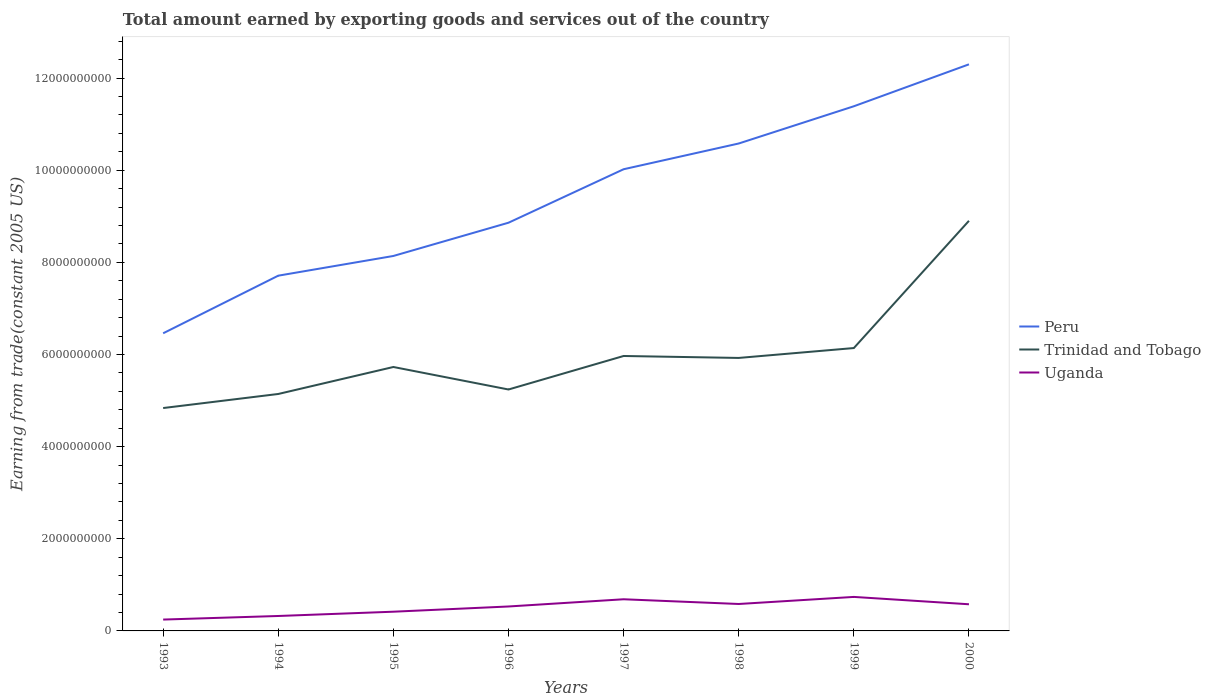Does the line corresponding to Peru intersect with the line corresponding to Trinidad and Tobago?
Make the answer very short. No. Is the number of lines equal to the number of legend labels?
Offer a very short reply. Yes. Across all years, what is the maximum total amount earned by exporting goods and services in Peru?
Give a very brief answer. 6.46e+09. In which year was the total amount earned by exporting goods and services in Trinidad and Tobago maximum?
Keep it short and to the point. 1993. What is the total total amount earned by exporting goods and services in Trinidad and Tobago in the graph?
Make the answer very short. -2.98e+09. What is the difference between the highest and the second highest total amount earned by exporting goods and services in Peru?
Give a very brief answer. 5.84e+09. How many lines are there?
Your response must be concise. 3. Are the values on the major ticks of Y-axis written in scientific E-notation?
Offer a very short reply. No. Does the graph contain grids?
Your response must be concise. No. How are the legend labels stacked?
Keep it short and to the point. Vertical. What is the title of the graph?
Offer a terse response. Total amount earned by exporting goods and services out of the country. What is the label or title of the Y-axis?
Your response must be concise. Earning from trade(constant 2005 US). What is the Earning from trade(constant 2005 US) of Peru in 1993?
Your answer should be compact. 6.46e+09. What is the Earning from trade(constant 2005 US) in Trinidad and Tobago in 1993?
Ensure brevity in your answer.  4.84e+09. What is the Earning from trade(constant 2005 US) in Uganda in 1993?
Offer a very short reply. 2.46e+08. What is the Earning from trade(constant 2005 US) in Peru in 1994?
Give a very brief answer. 7.71e+09. What is the Earning from trade(constant 2005 US) of Trinidad and Tobago in 1994?
Provide a succinct answer. 5.14e+09. What is the Earning from trade(constant 2005 US) in Uganda in 1994?
Your answer should be very brief. 3.24e+08. What is the Earning from trade(constant 2005 US) in Peru in 1995?
Provide a succinct answer. 8.14e+09. What is the Earning from trade(constant 2005 US) of Trinidad and Tobago in 1995?
Keep it short and to the point. 5.73e+09. What is the Earning from trade(constant 2005 US) of Uganda in 1995?
Ensure brevity in your answer.  4.17e+08. What is the Earning from trade(constant 2005 US) in Peru in 1996?
Provide a succinct answer. 8.86e+09. What is the Earning from trade(constant 2005 US) of Trinidad and Tobago in 1996?
Ensure brevity in your answer.  5.24e+09. What is the Earning from trade(constant 2005 US) of Uganda in 1996?
Your answer should be very brief. 5.31e+08. What is the Earning from trade(constant 2005 US) of Peru in 1997?
Provide a succinct answer. 1.00e+1. What is the Earning from trade(constant 2005 US) of Trinidad and Tobago in 1997?
Ensure brevity in your answer.  5.97e+09. What is the Earning from trade(constant 2005 US) in Uganda in 1997?
Your answer should be compact. 6.87e+08. What is the Earning from trade(constant 2005 US) in Peru in 1998?
Your answer should be very brief. 1.06e+1. What is the Earning from trade(constant 2005 US) in Trinidad and Tobago in 1998?
Provide a succinct answer. 5.93e+09. What is the Earning from trade(constant 2005 US) of Uganda in 1998?
Your answer should be very brief. 5.85e+08. What is the Earning from trade(constant 2005 US) in Peru in 1999?
Offer a terse response. 1.14e+1. What is the Earning from trade(constant 2005 US) of Trinidad and Tobago in 1999?
Keep it short and to the point. 6.14e+09. What is the Earning from trade(constant 2005 US) of Uganda in 1999?
Offer a terse response. 7.38e+08. What is the Earning from trade(constant 2005 US) in Peru in 2000?
Provide a succinct answer. 1.23e+1. What is the Earning from trade(constant 2005 US) in Trinidad and Tobago in 2000?
Your answer should be compact. 8.90e+09. What is the Earning from trade(constant 2005 US) in Uganda in 2000?
Your response must be concise. 5.79e+08. Across all years, what is the maximum Earning from trade(constant 2005 US) of Peru?
Provide a succinct answer. 1.23e+1. Across all years, what is the maximum Earning from trade(constant 2005 US) in Trinidad and Tobago?
Give a very brief answer. 8.90e+09. Across all years, what is the maximum Earning from trade(constant 2005 US) of Uganda?
Your response must be concise. 7.38e+08. Across all years, what is the minimum Earning from trade(constant 2005 US) in Peru?
Your answer should be compact. 6.46e+09. Across all years, what is the minimum Earning from trade(constant 2005 US) of Trinidad and Tobago?
Your response must be concise. 4.84e+09. Across all years, what is the minimum Earning from trade(constant 2005 US) of Uganda?
Give a very brief answer. 2.46e+08. What is the total Earning from trade(constant 2005 US) of Peru in the graph?
Offer a very short reply. 7.55e+1. What is the total Earning from trade(constant 2005 US) of Trinidad and Tobago in the graph?
Give a very brief answer. 4.79e+1. What is the total Earning from trade(constant 2005 US) of Uganda in the graph?
Ensure brevity in your answer.  4.11e+09. What is the difference between the Earning from trade(constant 2005 US) of Peru in 1993 and that in 1994?
Keep it short and to the point. -1.25e+09. What is the difference between the Earning from trade(constant 2005 US) in Trinidad and Tobago in 1993 and that in 1994?
Make the answer very short. -3.05e+08. What is the difference between the Earning from trade(constant 2005 US) in Uganda in 1993 and that in 1994?
Keep it short and to the point. -7.77e+07. What is the difference between the Earning from trade(constant 2005 US) of Peru in 1993 and that in 1995?
Your answer should be very brief. -1.68e+09. What is the difference between the Earning from trade(constant 2005 US) in Trinidad and Tobago in 1993 and that in 1995?
Offer a terse response. -8.91e+08. What is the difference between the Earning from trade(constant 2005 US) of Uganda in 1993 and that in 1995?
Make the answer very short. -1.71e+08. What is the difference between the Earning from trade(constant 2005 US) in Peru in 1993 and that in 1996?
Provide a short and direct response. -2.40e+09. What is the difference between the Earning from trade(constant 2005 US) in Trinidad and Tobago in 1993 and that in 1996?
Offer a very short reply. -4.03e+08. What is the difference between the Earning from trade(constant 2005 US) in Uganda in 1993 and that in 1996?
Your answer should be very brief. -2.84e+08. What is the difference between the Earning from trade(constant 2005 US) of Peru in 1993 and that in 1997?
Keep it short and to the point. -3.56e+09. What is the difference between the Earning from trade(constant 2005 US) in Trinidad and Tobago in 1993 and that in 1997?
Make the answer very short. -1.13e+09. What is the difference between the Earning from trade(constant 2005 US) in Uganda in 1993 and that in 1997?
Provide a short and direct response. -4.41e+08. What is the difference between the Earning from trade(constant 2005 US) in Peru in 1993 and that in 1998?
Keep it short and to the point. -4.12e+09. What is the difference between the Earning from trade(constant 2005 US) in Trinidad and Tobago in 1993 and that in 1998?
Your answer should be compact. -1.09e+09. What is the difference between the Earning from trade(constant 2005 US) of Uganda in 1993 and that in 1998?
Your answer should be compact. -3.38e+08. What is the difference between the Earning from trade(constant 2005 US) in Peru in 1993 and that in 1999?
Your answer should be compact. -4.93e+09. What is the difference between the Earning from trade(constant 2005 US) in Trinidad and Tobago in 1993 and that in 1999?
Give a very brief answer. -1.30e+09. What is the difference between the Earning from trade(constant 2005 US) in Uganda in 1993 and that in 1999?
Ensure brevity in your answer.  -4.92e+08. What is the difference between the Earning from trade(constant 2005 US) in Peru in 1993 and that in 2000?
Your response must be concise. -5.84e+09. What is the difference between the Earning from trade(constant 2005 US) in Trinidad and Tobago in 1993 and that in 2000?
Your response must be concise. -4.06e+09. What is the difference between the Earning from trade(constant 2005 US) of Uganda in 1993 and that in 2000?
Give a very brief answer. -3.32e+08. What is the difference between the Earning from trade(constant 2005 US) in Peru in 1994 and that in 1995?
Make the answer very short. -4.28e+08. What is the difference between the Earning from trade(constant 2005 US) of Trinidad and Tobago in 1994 and that in 1995?
Keep it short and to the point. -5.86e+08. What is the difference between the Earning from trade(constant 2005 US) in Uganda in 1994 and that in 1995?
Your answer should be compact. -9.28e+07. What is the difference between the Earning from trade(constant 2005 US) of Peru in 1994 and that in 1996?
Your answer should be compact. -1.15e+09. What is the difference between the Earning from trade(constant 2005 US) of Trinidad and Tobago in 1994 and that in 1996?
Give a very brief answer. -9.74e+07. What is the difference between the Earning from trade(constant 2005 US) of Uganda in 1994 and that in 1996?
Provide a short and direct response. -2.06e+08. What is the difference between the Earning from trade(constant 2005 US) of Peru in 1994 and that in 1997?
Give a very brief answer. -2.31e+09. What is the difference between the Earning from trade(constant 2005 US) of Trinidad and Tobago in 1994 and that in 1997?
Make the answer very short. -8.25e+08. What is the difference between the Earning from trade(constant 2005 US) of Uganda in 1994 and that in 1997?
Your answer should be compact. -3.63e+08. What is the difference between the Earning from trade(constant 2005 US) of Peru in 1994 and that in 1998?
Offer a terse response. -2.87e+09. What is the difference between the Earning from trade(constant 2005 US) of Trinidad and Tobago in 1994 and that in 1998?
Provide a short and direct response. -7.83e+08. What is the difference between the Earning from trade(constant 2005 US) of Uganda in 1994 and that in 1998?
Make the answer very short. -2.60e+08. What is the difference between the Earning from trade(constant 2005 US) in Peru in 1994 and that in 1999?
Your response must be concise. -3.68e+09. What is the difference between the Earning from trade(constant 2005 US) of Trinidad and Tobago in 1994 and that in 1999?
Offer a very short reply. -9.97e+08. What is the difference between the Earning from trade(constant 2005 US) in Uganda in 1994 and that in 1999?
Give a very brief answer. -4.14e+08. What is the difference between the Earning from trade(constant 2005 US) of Peru in 1994 and that in 2000?
Offer a terse response. -4.59e+09. What is the difference between the Earning from trade(constant 2005 US) of Trinidad and Tobago in 1994 and that in 2000?
Keep it short and to the point. -3.76e+09. What is the difference between the Earning from trade(constant 2005 US) in Uganda in 1994 and that in 2000?
Offer a terse response. -2.54e+08. What is the difference between the Earning from trade(constant 2005 US) of Peru in 1995 and that in 1996?
Offer a very short reply. -7.22e+08. What is the difference between the Earning from trade(constant 2005 US) of Trinidad and Tobago in 1995 and that in 1996?
Your response must be concise. 4.88e+08. What is the difference between the Earning from trade(constant 2005 US) in Uganda in 1995 and that in 1996?
Keep it short and to the point. -1.14e+08. What is the difference between the Earning from trade(constant 2005 US) of Peru in 1995 and that in 1997?
Offer a terse response. -1.88e+09. What is the difference between the Earning from trade(constant 2005 US) in Trinidad and Tobago in 1995 and that in 1997?
Your answer should be compact. -2.39e+08. What is the difference between the Earning from trade(constant 2005 US) in Uganda in 1995 and that in 1997?
Ensure brevity in your answer.  -2.70e+08. What is the difference between the Earning from trade(constant 2005 US) in Peru in 1995 and that in 1998?
Ensure brevity in your answer.  -2.44e+09. What is the difference between the Earning from trade(constant 2005 US) of Trinidad and Tobago in 1995 and that in 1998?
Your answer should be very brief. -1.97e+08. What is the difference between the Earning from trade(constant 2005 US) of Uganda in 1995 and that in 1998?
Your answer should be very brief. -1.68e+08. What is the difference between the Earning from trade(constant 2005 US) of Peru in 1995 and that in 1999?
Offer a very short reply. -3.25e+09. What is the difference between the Earning from trade(constant 2005 US) of Trinidad and Tobago in 1995 and that in 1999?
Offer a very short reply. -4.11e+08. What is the difference between the Earning from trade(constant 2005 US) of Uganda in 1995 and that in 1999?
Offer a very short reply. -3.21e+08. What is the difference between the Earning from trade(constant 2005 US) in Peru in 1995 and that in 2000?
Make the answer very short. -4.16e+09. What is the difference between the Earning from trade(constant 2005 US) in Trinidad and Tobago in 1995 and that in 2000?
Your answer should be compact. -3.17e+09. What is the difference between the Earning from trade(constant 2005 US) of Uganda in 1995 and that in 2000?
Give a very brief answer. -1.62e+08. What is the difference between the Earning from trade(constant 2005 US) in Peru in 1996 and that in 1997?
Give a very brief answer. -1.16e+09. What is the difference between the Earning from trade(constant 2005 US) in Trinidad and Tobago in 1996 and that in 1997?
Make the answer very short. -7.27e+08. What is the difference between the Earning from trade(constant 2005 US) in Uganda in 1996 and that in 1997?
Give a very brief answer. -1.56e+08. What is the difference between the Earning from trade(constant 2005 US) of Peru in 1996 and that in 1998?
Your response must be concise. -1.72e+09. What is the difference between the Earning from trade(constant 2005 US) in Trinidad and Tobago in 1996 and that in 1998?
Your answer should be compact. -6.85e+08. What is the difference between the Earning from trade(constant 2005 US) of Uganda in 1996 and that in 1998?
Offer a terse response. -5.41e+07. What is the difference between the Earning from trade(constant 2005 US) in Peru in 1996 and that in 1999?
Keep it short and to the point. -2.53e+09. What is the difference between the Earning from trade(constant 2005 US) of Trinidad and Tobago in 1996 and that in 1999?
Ensure brevity in your answer.  -9.00e+08. What is the difference between the Earning from trade(constant 2005 US) in Uganda in 1996 and that in 1999?
Make the answer very short. -2.08e+08. What is the difference between the Earning from trade(constant 2005 US) in Peru in 1996 and that in 2000?
Provide a short and direct response. -3.44e+09. What is the difference between the Earning from trade(constant 2005 US) of Trinidad and Tobago in 1996 and that in 2000?
Provide a short and direct response. -3.66e+09. What is the difference between the Earning from trade(constant 2005 US) of Uganda in 1996 and that in 2000?
Offer a terse response. -4.81e+07. What is the difference between the Earning from trade(constant 2005 US) in Peru in 1997 and that in 1998?
Offer a very short reply. -5.59e+08. What is the difference between the Earning from trade(constant 2005 US) in Trinidad and Tobago in 1997 and that in 1998?
Your answer should be very brief. 4.21e+07. What is the difference between the Earning from trade(constant 2005 US) in Uganda in 1997 and that in 1998?
Your response must be concise. 1.02e+08. What is the difference between the Earning from trade(constant 2005 US) of Peru in 1997 and that in 1999?
Your answer should be compact. -1.37e+09. What is the difference between the Earning from trade(constant 2005 US) in Trinidad and Tobago in 1997 and that in 1999?
Provide a short and direct response. -1.72e+08. What is the difference between the Earning from trade(constant 2005 US) in Uganda in 1997 and that in 1999?
Make the answer very short. -5.12e+07. What is the difference between the Earning from trade(constant 2005 US) in Peru in 1997 and that in 2000?
Provide a short and direct response. -2.28e+09. What is the difference between the Earning from trade(constant 2005 US) in Trinidad and Tobago in 1997 and that in 2000?
Keep it short and to the point. -2.93e+09. What is the difference between the Earning from trade(constant 2005 US) of Uganda in 1997 and that in 2000?
Your answer should be compact. 1.08e+08. What is the difference between the Earning from trade(constant 2005 US) in Peru in 1998 and that in 1999?
Ensure brevity in your answer.  -8.08e+08. What is the difference between the Earning from trade(constant 2005 US) in Trinidad and Tobago in 1998 and that in 1999?
Provide a succinct answer. -2.15e+08. What is the difference between the Earning from trade(constant 2005 US) in Uganda in 1998 and that in 1999?
Provide a succinct answer. -1.54e+08. What is the difference between the Earning from trade(constant 2005 US) of Peru in 1998 and that in 2000?
Provide a short and direct response. -1.72e+09. What is the difference between the Earning from trade(constant 2005 US) in Trinidad and Tobago in 1998 and that in 2000?
Give a very brief answer. -2.98e+09. What is the difference between the Earning from trade(constant 2005 US) in Uganda in 1998 and that in 2000?
Your answer should be very brief. 5.93e+06. What is the difference between the Earning from trade(constant 2005 US) in Peru in 1999 and that in 2000?
Your answer should be compact. -9.10e+08. What is the difference between the Earning from trade(constant 2005 US) of Trinidad and Tobago in 1999 and that in 2000?
Your response must be concise. -2.76e+09. What is the difference between the Earning from trade(constant 2005 US) in Uganda in 1999 and that in 2000?
Offer a terse response. 1.59e+08. What is the difference between the Earning from trade(constant 2005 US) in Peru in 1993 and the Earning from trade(constant 2005 US) in Trinidad and Tobago in 1994?
Keep it short and to the point. 1.32e+09. What is the difference between the Earning from trade(constant 2005 US) of Peru in 1993 and the Earning from trade(constant 2005 US) of Uganda in 1994?
Your answer should be very brief. 6.14e+09. What is the difference between the Earning from trade(constant 2005 US) in Trinidad and Tobago in 1993 and the Earning from trade(constant 2005 US) in Uganda in 1994?
Keep it short and to the point. 4.51e+09. What is the difference between the Earning from trade(constant 2005 US) of Peru in 1993 and the Earning from trade(constant 2005 US) of Trinidad and Tobago in 1995?
Offer a terse response. 7.32e+08. What is the difference between the Earning from trade(constant 2005 US) in Peru in 1993 and the Earning from trade(constant 2005 US) in Uganda in 1995?
Offer a terse response. 6.04e+09. What is the difference between the Earning from trade(constant 2005 US) in Trinidad and Tobago in 1993 and the Earning from trade(constant 2005 US) in Uganda in 1995?
Give a very brief answer. 4.42e+09. What is the difference between the Earning from trade(constant 2005 US) of Peru in 1993 and the Earning from trade(constant 2005 US) of Trinidad and Tobago in 1996?
Offer a very short reply. 1.22e+09. What is the difference between the Earning from trade(constant 2005 US) in Peru in 1993 and the Earning from trade(constant 2005 US) in Uganda in 1996?
Give a very brief answer. 5.93e+09. What is the difference between the Earning from trade(constant 2005 US) in Trinidad and Tobago in 1993 and the Earning from trade(constant 2005 US) in Uganda in 1996?
Keep it short and to the point. 4.31e+09. What is the difference between the Earning from trade(constant 2005 US) of Peru in 1993 and the Earning from trade(constant 2005 US) of Trinidad and Tobago in 1997?
Offer a terse response. 4.93e+08. What is the difference between the Earning from trade(constant 2005 US) of Peru in 1993 and the Earning from trade(constant 2005 US) of Uganda in 1997?
Provide a succinct answer. 5.77e+09. What is the difference between the Earning from trade(constant 2005 US) of Trinidad and Tobago in 1993 and the Earning from trade(constant 2005 US) of Uganda in 1997?
Give a very brief answer. 4.15e+09. What is the difference between the Earning from trade(constant 2005 US) in Peru in 1993 and the Earning from trade(constant 2005 US) in Trinidad and Tobago in 1998?
Provide a succinct answer. 5.35e+08. What is the difference between the Earning from trade(constant 2005 US) of Peru in 1993 and the Earning from trade(constant 2005 US) of Uganda in 1998?
Provide a short and direct response. 5.88e+09. What is the difference between the Earning from trade(constant 2005 US) of Trinidad and Tobago in 1993 and the Earning from trade(constant 2005 US) of Uganda in 1998?
Make the answer very short. 4.25e+09. What is the difference between the Earning from trade(constant 2005 US) of Peru in 1993 and the Earning from trade(constant 2005 US) of Trinidad and Tobago in 1999?
Provide a short and direct response. 3.20e+08. What is the difference between the Earning from trade(constant 2005 US) in Peru in 1993 and the Earning from trade(constant 2005 US) in Uganda in 1999?
Offer a terse response. 5.72e+09. What is the difference between the Earning from trade(constant 2005 US) in Trinidad and Tobago in 1993 and the Earning from trade(constant 2005 US) in Uganda in 1999?
Provide a short and direct response. 4.10e+09. What is the difference between the Earning from trade(constant 2005 US) of Peru in 1993 and the Earning from trade(constant 2005 US) of Trinidad and Tobago in 2000?
Give a very brief answer. -2.44e+09. What is the difference between the Earning from trade(constant 2005 US) in Peru in 1993 and the Earning from trade(constant 2005 US) in Uganda in 2000?
Give a very brief answer. 5.88e+09. What is the difference between the Earning from trade(constant 2005 US) in Trinidad and Tobago in 1993 and the Earning from trade(constant 2005 US) in Uganda in 2000?
Keep it short and to the point. 4.26e+09. What is the difference between the Earning from trade(constant 2005 US) in Peru in 1994 and the Earning from trade(constant 2005 US) in Trinidad and Tobago in 1995?
Ensure brevity in your answer.  1.98e+09. What is the difference between the Earning from trade(constant 2005 US) of Peru in 1994 and the Earning from trade(constant 2005 US) of Uganda in 1995?
Provide a succinct answer. 7.29e+09. What is the difference between the Earning from trade(constant 2005 US) of Trinidad and Tobago in 1994 and the Earning from trade(constant 2005 US) of Uganda in 1995?
Your answer should be compact. 4.73e+09. What is the difference between the Earning from trade(constant 2005 US) in Peru in 1994 and the Earning from trade(constant 2005 US) in Trinidad and Tobago in 1996?
Provide a short and direct response. 2.47e+09. What is the difference between the Earning from trade(constant 2005 US) of Peru in 1994 and the Earning from trade(constant 2005 US) of Uganda in 1996?
Provide a short and direct response. 7.18e+09. What is the difference between the Earning from trade(constant 2005 US) in Trinidad and Tobago in 1994 and the Earning from trade(constant 2005 US) in Uganda in 1996?
Offer a very short reply. 4.61e+09. What is the difference between the Earning from trade(constant 2005 US) of Peru in 1994 and the Earning from trade(constant 2005 US) of Trinidad and Tobago in 1997?
Ensure brevity in your answer.  1.74e+09. What is the difference between the Earning from trade(constant 2005 US) in Peru in 1994 and the Earning from trade(constant 2005 US) in Uganda in 1997?
Offer a very short reply. 7.02e+09. What is the difference between the Earning from trade(constant 2005 US) of Trinidad and Tobago in 1994 and the Earning from trade(constant 2005 US) of Uganda in 1997?
Your answer should be very brief. 4.46e+09. What is the difference between the Earning from trade(constant 2005 US) of Peru in 1994 and the Earning from trade(constant 2005 US) of Trinidad and Tobago in 1998?
Offer a very short reply. 1.79e+09. What is the difference between the Earning from trade(constant 2005 US) in Peru in 1994 and the Earning from trade(constant 2005 US) in Uganda in 1998?
Make the answer very short. 7.13e+09. What is the difference between the Earning from trade(constant 2005 US) of Trinidad and Tobago in 1994 and the Earning from trade(constant 2005 US) of Uganda in 1998?
Provide a succinct answer. 4.56e+09. What is the difference between the Earning from trade(constant 2005 US) in Peru in 1994 and the Earning from trade(constant 2005 US) in Trinidad and Tobago in 1999?
Your response must be concise. 1.57e+09. What is the difference between the Earning from trade(constant 2005 US) of Peru in 1994 and the Earning from trade(constant 2005 US) of Uganda in 1999?
Offer a terse response. 6.97e+09. What is the difference between the Earning from trade(constant 2005 US) of Trinidad and Tobago in 1994 and the Earning from trade(constant 2005 US) of Uganda in 1999?
Make the answer very short. 4.41e+09. What is the difference between the Earning from trade(constant 2005 US) in Peru in 1994 and the Earning from trade(constant 2005 US) in Trinidad and Tobago in 2000?
Your answer should be very brief. -1.19e+09. What is the difference between the Earning from trade(constant 2005 US) of Peru in 1994 and the Earning from trade(constant 2005 US) of Uganda in 2000?
Provide a short and direct response. 7.13e+09. What is the difference between the Earning from trade(constant 2005 US) of Trinidad and Tobago in 1994 and the Earning from trade(constant 2005 US) of Uganda in 2000?
Your answer should be compact. 4.56e+09. What is the difference between the Earning from trade(constant 2005 US) in Peru in 1995 and the Earning from trade(constant 2005 US) in Trinidad and Tobago in 1996?
Offer a terse response. 2.90e+09. What is the difference between the Earning from trade(constant 2005 US) of Peru in 1995 and the Earning from trade(constant 2005 US) of Uganda in 1996?
Provide a succinct answer. 7.61e+09. What is the difference between the Earning from trade(constant 2005 US) of Trinidad and Tobago in 1995 and the Earning from trade(constant 2005 US) of Uganda in 1996?
Provide a succinct answer. 5.20e+09. What is the difference between the Earning from trade(constant 2005 US) of Peru in 1995 and the Earning from trade(constant 2005 US) of Trinidad and Tobago in 1997?
Your response must be concise. 2.17e+09. What is the difference between the Earning from trade(constant 2005 US) in Peru in 1995 and the Earning from trade(constant 2005 US) in Uganda in 1997?
Your answer should be very brief. 7.45e+09. What is the difference between the Earning from trade(constant 2005 US) in Trinidad and Tobago in 1995 and the Earning from trade(constant 2005 US) in Uganda in 1997?
Offer a very short reply. 5.04e+09. What is the difference between the Earning from trade(constant 2005 US) of Peru in 1995 and the Earning from trade(constant 2005 US) of Trinidad and Tobago in 1998?
Make the answer very short. 2.21e+09. What is the difference between the Earning from trade(constant 2005 US) in Peru in 1995 and the Earning from trade(constant 2005 US) in Uganda in 1998?
Provide a succinct answer. 7.55e+09. What is the difference between the Earning from trade(constant 2005 US) of Trinidad and Tobago in 1995 and the Earning from trade(constant 2005 US) of Uganda in 1998?
Your answer should be compact. 5.14e+09. What is the difference between the Earning from trade(constant 2005 US) in Peru in 1995 and the Earning from trade(constant 2005 US) in Trinidad and Tobago in 1999?
Provide a succinct answer. 2.00e+09. What is the difference between the Earning from trade(constant 2005 US) of Peru in 1995 and the Earning from trade(constant 2005 US) of Uganda in 1999?
Ensure brevity in your answer.  7.40e+09. What is the difference between the Earning from trade(constant 2005 US) of Trinidad and Tobago in 1995 and the Earning from trade(constant 2005 US) of Uganda in 1999?
Provide a short and direct response. 4.99e+09. What is the difference between the Earning from trade(constant 2005 US) in Peru in 1995 and the Earning from trade(constant 2005 US) in Trinidad and Tobago in 2000?
Keep it short and to the point. -7.63e+08. What is the difference between the Earning from trade(constant 2005 US) in Peru in 1995 and the Earning from trade(constant 2005 US) in Uganda in 2000?
Offer a very short reply. 7.56e+09. What is the difference between the Earning from trade(constant 2005 US) in Trinidad and Tobago in 1995 and the Earning from trade(constant 2005 US) in Uganda in 2000?
Offer a terse response. 5.15e+09. What is the difference between the Earning from trade(constant 2005 US) in Peru in 1996 and the Earning from trade(constant 2005 US) in Trinidad and Tobago in 1997?
Provide a short and direct response. 2.89e+09. What is the difference between the Earning from trade(constant 2005 US) of Peru in 1996 and the Earning from trade(constant 2005 US) of Uganda in 1997?
Give a very brief answer. 8.17e+09. What is the difference between the Earning from trade(constant 2005 US) of Trinidad and Tobago in 1996 and the Earning from trade(constant 2005 US) of Uganda in 1997?
Your answer should be compact. 4.55e+09. What is the difference between the Earning from trade(constant 2005 US) of Peru in 1996 and the Earning from trade(constant 2005 US) of Trinidad and Tobago in 1998?
Ensure brevity in your answer.  2.94e+09. What is the difference between the Earning from trade(constant 2005 US) of Peru in 1996 and the Earning from trade(constant 2005 US) of Uganda in 1998?
Ensure brevity in your answer.  8.28e+09. What is the difference between the Earning from trade(constant 2005 US) in Trinidad and Tobago in 1996 and the Earning from trade(constant 2005 US) in Uganda in 1998?
Offer a terse response. 4.66e+09. What is the difference between the Earning from trade(constant 2005 US) in Peru in 1996 and the Earning from trade(constant 2005 US) in Trinidad and Tobago in 1999?
Provide a short and direct response. 2.72e+09. What is the difference between the Earning from trade(constant 2005 US) in Peru in 1996 and the Earning from trade(constant 2005 US) in Uganda in 1999?
Give a very brief answer. 8.12e+09. What is the difference between the Earning from trade(constant 2005 US) in Trinidad and Tobago in 1996 and the Earning from trade(constant 2005 US) in Uganda in 1999?
Give a very brief answer. 4.50e+09. What is the difference between the Earning from trade(constant 2005 US) of Peru in 1996 and the Earning from trade(constant 2005 US) of Trinidad and Tobago in 2000?
Make the answer very short. -4.17e+07. What is the difference between the Earning from trade(constant 2005 US) of Peru in 1996 and the Earning from trade(constant 2005 US) of Uganda in 2000?
Make the answer very short. 8.28e+09. What is the difference between the Earning from trade(constant 2005 US) of Trinidad and Tobago in 1996 and the Earning from trade(constant 2005 US) of Uganda in 2000?
Your answer should be compact. 4.66e+09. What is the difference between the Earning from trade(constant 2005 US) of Peru in 1997 and the Earning from trade(constant 2005 US) of Trinidad and Tobago in 1998?
Give a very brief answer. 4.10e+09. What is the difference between the Earning from trade(constant 2005 US) in Peru in 1997 and the Earning from trade(constant 2005 US) in Uganda in 1998?
Your response must be concise. 9.44e+09. What is the difference between the Earning from trade(constant 2005 US) of Trinidad and Tobago in 1997 and the Earning from trade(constant 2005 US) of Uganda in 1998?
Your response must be concise. 5.38e+09. What is the difference between the Earning from trade(constant 2005 US) in Peru in 1997 and the Earning from trade(constant 2005 US) in Trinidad and Tobago in 1999?
Provide a short and direct response. 3.88e+09. What is the difference between the Earning from trade(constant 2005 US) of Peru in 1997 and the Earning from trade(constant 2005 US) of Uganda in 1999?
Provide a short and direct response. 9.28e+09. What is the difference between the Earning from trade(constant 2005 US) in Trinidad and Tobago in 1997 and the Earning from trade(constant 2005 US) in Uganda in 1999?
Offer a terse response. 5.23e+09. What is the difference between the Earning from trade(constant 2005 US) of Peru in 1997 and the Earning from trade(constant 2005 US) of Trinidad and Tobago in 2000?
Provide a succinct answer. 1.12e+09. What is the difference between the Earning from trade(constant 2005 US) of Peru in 1997 and the Earning from trade(constant 2005 US) of Uganda in 2000?
Make the answer very short. 9.44e+09. What is the difference between the Earning from trade(constant 2005 US) in Trinidad and Tobago in 1997 and the Earning from trade(constant 2005 US) in Uganda in 2000?
Provide a short and direct response. 5.39e+09. What is the difference between the Earning from trade(constant 2005 US) in Peru in 1998 and the Earning from trade(constant 2005 US) in Trinidad and Tobago in 1999?
Your answer should be very brief. 4.44e+09. What is the difference between the Earning from trade(constant 2005 US) in Peru in 1998 and the Earning from trade(constant 2005 US) in Uganda in 1999?
Make the answer very short. 9.84e+09. What is the difference between the Earning from trade(constant 2005 US) of Trinidad and Tobago in 1998 and the Earning from trade(constant 2005 US) of Uganda in 1999?
Your answer should be compact. 5.19e+09. What is the difference between the Earning from trade(constant 2005 US) in Peru in 1998 and the Earning from trade(constant 2005 US) in Trinidad and Tobago in 2000?
Give a very brief answer. 1.68e+09. What is the difference between the Earning from trade(constant 2005 US) of Peru in 1998 and the Earning from trade(constant 2005 US) of Uganda in 2000?
Provide a short and direct response. 1.00e+1. What is the difference between the Earning from trade(constant 2005 US) in Trinidad and Tobago in 1998 and the Earning from trade(constant 2005 US) in Uganda in 2000?
Give a very brief answer. 5.35e+09. What is the difference between the Earning from trade(constant 2005 US) in Peru in 1999 and the Earning from trade(constant 2005 US) in Trinidad and Tobago in 2000?
Your answer should be compact. 2.49e+09. What is the difference between the Earning from trade(constant 2005 US) of Peru in 1999 and the Earning from trade(constant 2005 US) of Uganda in 2000?
Make the answer very short. 1.08e+1. What is the difference between the Earning from trade(constant 2005 US) in Trinidad and Tobago in 1999 and the Earning from trade(constant 2005 US) in Uganda in 2000?
Provide a succinct answer. 5.56e+09. What is the average Earning from trade(constant 2005 US) of Peru per year?
Make the answer very short. 9.43e+09. What is the average Earning from trade(constant 2005 US) of Trinidad and Tobago per year?
Ensure brevity in your answer.  5.99e+09. What is the average Earning from trade(constant 2005 US) in Uganda per year?
Your answer should be very brief. 5.13e+08. In the year 1993, what is the difference between the Earning from trade(constant 2005 US) of Peru and Earning from trade(constant 2005 US) of Trinidad and Tobago?
Offer a terse response. 1.62e+09. In the year 1993, what is the difference between the Earning from trade(constant 2005 US) in Peru and Earning from trade(constant 2005 US) in Uganda?
Ensure brevity in your answer.  6.21e+09. In the year 1993, what is the difference between the Earning from trade(constant 2005 US) of Trinidad and Tobago and Earning from trade(constant 2005 US) of Uganda?
Provide a short and direct response. 4.59e+09. In the year 1994, what is the difference between the Earning from trade(constant 2005 US) of Peru and Earning from trade(constant 2005 US) of Trinidad and Tobago?
Provide a succinct answer. 2.57e+09. In the year 1994, what is the difference between the Earning from trade(constant 2005 US) in Peru and Earning from trade(constant 2005 US) in Uganda?
Your answer should be very brief. 7.39e+09. In the year 1994, what is the difference between the Earning from trade(constant 2005 US) in Trinidad and Tobago and Earning from trade(constant 2005 US) in Uganda?
Your response must be concise. 4.82e+09. In the year 1995, what is the difference between the Earning from trade(constant 2005 US) in Peru and Earning from trade(constant 2005 US) in Trinidad and Tobago?
Offer a very short reply. 2.41e+09. In the year 1995, what is the difference between the Earning from trade(constant 2005 US) of Peru and Earning from trade(constant 2005 US) of Uganda?
Provide a succinct answer. 7.72e+09. In the year 1995, what is the difference between the Earning from trade(constant 2005 US) of Trinidad and Tobago and Earning from trade(constant 2005 US) of Uganda?
Ensure brevity in your answer.  5.31e+09. In the year 1996, what is the difference between the Earning from trade(constant 2005 US) in Peru and Earning from trade(constant 2005 US) in Trinidad and Tobago?
Offer a terse response. 3.62e+09. In the year 1996, what is the difference between the Earning from trade(constant 2005 US) of Peru and Earning from trade(constant 2005 US) of Uganda?
Your answer should be very brief. 8.33e+09. In the year 1996, what is the difference between the Earning from trade(constant 2005 US) of Trinidad and Tobago and Earning from trade(constant 2005 US) of Uganda?
Your answer should be compact. 4.71e+09. In the year 1997, what is the difference between the Earning from trade(constant 2005 US) in Peru and Earning from trade(constant 2005 US) in Trinidad and Tobago?
Make the answer very short. 4.05e+09. In the year 1997, what is the difference between the Earning from trade(constant 2005 US) in Peru and Earning from trade(constant 2005 US) in Uganda?
Your answer should be very brief. 9.33e+09. In the year 1997, what is the difference between the Earning from trade(constant 2005 US) in Trinidad and Tobago and Earning from trade(constant 2005 US) in Uganda?
Give a very brief answer. 5.28e+09. In the year 1998, what is the difference between the Earning from trade(constant 2005 US) in Peru and Earning from trade(constant 2005 US) in Trinidad and Tobago?
Provide a short and direct response. 4.65e+09. In the year 1998, what is the difference between the Earning from trade(constant 2005 US) in Peru and Earning from trade(constant 2005 US) in Uganda?
Give a very brief answer. 1.00e+1. In the year 1998, what is the difference between the Earning from trade(constant 2005 US) in Trinidad and Tobago and Earning from trade(constant 2005 US) in Uganda?
Keep it short and to the point. 5.34e+09. In the year 1999, what is the difference between the Earning from trade(constant 2005 US) of Peru and Earning from trade(constant 2005 US) of Trinidad and Tobago?
Ensure brevity in your answer.  5.25e+09. In the year 1999, what is the difference between the Earning from trade(constant 2005 US) of Peru and Earning from trade(constant 2005 US) of Uganda?
Give a very brief answer. 1.07e+1. In the year 1999, what is the difference between the Earning from trade(constant 2005 US) in Trinidad and Tobago and Earning from trade(constant 2005 US) in Uganda?
Offer a terse response. 5.40e+09. In the year 2000, what is the difference between the Earning from trade(constant 2005 US) of Peru and Earning from trade(constant 2005 US) of Trinidad and Tobago?
Give a very brief answer. 3.40e+09. In the year 2000, what is the difference between the Earning from trade(constant 2005 US) of Peru and Earning from trade(constant 2005 US) of Uganda?
Provide a short and direct response. 1.17e+1. In the year 2000, what is the difference between the Earning from trade(constant 2005 US) in Trinidad and Tobago and Earning from trade(constant 2005 US) in Uganda?
Ensure brevity in your answer.  8.32e+09. What is the ratio of the Earning from trade(constant 2005 US) of Peru in 1993 to that in 1994?
Your answer should be compact. 0.84. What is the ratio of the Earning from trade(constant 2005 US) in Trinidad and Tobago in 1993 to that in 1994?
Ensure brevity in your answer.  0.94. What is the ratio of the Earning from trade(constant 2005 US) of Uganda in 1993 to that in 1994?
Ensure brevity in your answer.  0.76. What is the ratio of the Earning from trade(constant 2005 US) in Peru in 1993 to that in 1995?
Your answer should be compact. 0.79. What is the ratio of the Earning from trade(constant 2005 US) of Trinidad and Tobago in 1993 to that in 1995?
Provide a succinct answer. 0.84. What is the ratio of the Earning from trade(constant 2005 US) in Uganda in 1993 to that in 1995?
Your answer should be compact. 0.59. What is the ratio of the Earning from trade(constant 2005 US) of Peru in 1993 to that in 1996?
Your response must be concise. 0.73. What is the ratio of the Earning from trade(constant 2005 US) of Trinidad and Tobago in 1993 to that in 1996?
Ensure brevity in your answer.  0.92. What is the ratio of the Earning from trade(constant 2005 US) of Uganda in 1993 to that in 1996?
Your response must be concise. 0.46. What is the ratio of the Earning from trade(constant 2005 US) in Peru in 1993 to that in 1997?
Your response must be concise. 0.64. What is the ratio of the Earning from trade(constant 2005 US) in Trinidad and Tobago in 1993 to that in 1997?
Give a very brief answer. 0.81. What is the ratio of the Earning from trade(constant 2005 US) in Uganda in 1993 to that in 1997?
Your answer should be very brief. 0.36. What is the ratio of the Earning from trade(constant 2005 US) in Peru in 1993 to that in 1998?
Provide a succinct answer. 0.61. What is the ratio of the Earning from trade(constant 2005 US) of Trinidad and Tobago in 1993 to that in 1998?
Give a very brief answer. 0.82. What is the ratio of the Earning from trade(constant 2005 US) of Uganda in 1993 to that in 1998?
Provide a succinct answer. 0.42. What is the ratio of the Earning from trade(constant 2005 US) in Peru in 1993 to that in 1999?
Offer a terse response. 0.57. What is the ratio of the Earning from trade(constant 2005 US) in Trinidad and Tobago in 1993 to that in 1999?
Keep it short and to the point. 0.79. What is the ratio of the Earning from trade(constant 2005 US) in Uganda in 1993 to that in 1999?
Make the answer very short. 0.33. What is the ratio of the Earning from trade(constant 2005 US) of Peru in 1993 to that in 2000?
Provide a short and direct response. 0.53. What is the ratio of the Earning from trade(constant 2005 US) of Trinidad and Tobago in 1993 to that in 2000?
Provide a short and direct response. 0.54. What is the ratio of the Earning from trade(constant 2005 US) of Uganda in 1993 to that in 2000?
Keep it short and to the point. 0.43. What is the ratio of the Earning from trade(constant 2005 US) in Peru in 1994 to that in 1995?
Your answer should be compact. 0.95. What is the ratio of the Earning from trade(constant 2005 US) in Trinidad and Tobago in 1994 to that in 1995?
Your answer should be very brief. 0.9. What is the ratio of the Earning from trade(constant 2005 US) of Uganda in 1994 to that in 1995?
Offer a very short reply. 0.78. What is the ratio of the Earning from trade(constant 2005 US) in Peru in 1994 to that in 1996?
Make the answer very short. 0.87. What is the ratio of the Earning from trade(constant 2005 US) of Trinidad and Tobago in 1994 to that in 1996?
Give a very brief answer. 0.98. What is the ratio of the Earning from trade(constant 2005 US) of Uganda in 1994 to that in 1996?
Your response must be concise. 0.61. What is the ratio of the Earning from trade(constant 2005 US) of Peru in 1994 to that in 1997?
Provide a succinct answer. 0.77. What is the ratio of the Earning from trade(constant 2005 US) in Trinidad and Tobago in 1994 to that in 1997?
Make the answer very short. 0.86. What is the ratio of the Earning from trade(constant 2005 US) in Uganda in 1994 to that in 1997?
Give a very brief answer. 0.47. What is the ratio of the Earning from trade(constant 2005 US) of Peru in 1994 to that in 1998?
Offer a terse response. 0.73. What is the ratio of the Earning from trade(constant 2005 US) in Trinidad and Tobago in 1994 to that in 1998?
Provide a succinct answer. 0.87. What is the ratio of the Earning from trade(constant 2005 US) in Uganda in 1994 to that in 1998?
Your response must be concise. 0.55. What is the ratio of the Earning from trade(constant 2005 US) in Peru in 1994 to that in 1999?
Offer a terse response. 0.68. What is the ratio of the Earning from trade(constant 2005 US) in Trinidad and Tobago in 1994 to that in 1999?
Make the answer very short. 0.84. What is the ratio of the Earning from trade(constant 2005 US) of Uganda in 1994 to that in 1999?
Make the answer very short. 0.44. What is the ratio of the Earning from trade(constant 2005 US) in Peru in 1994 to that in 2000?
Provide a short and direct response. 0.63. What is the ratio of the Earning from trade(constant 2005 US) in Trinidad and Tobago in 1994 to that in 2000?
Your answer should be compact. 0.58. What is the ratio of the Earning from trade(constant 2005 US) in Uganda in 1994 to that in 2000?
Offer a terse response. 0.56. What is the ratio of the Earning from trade(constant 2005 US) in Peru in 1995 to that in 1996?
Your answer should be compact. 0.92. What is the ratio of the Earning from trade(constant 2005 US) in Trinidad and Tobago in 1995 to that in 1996?
Offer a very short reply. 1.09. What is the ratio of the Earning from trade(constant 2005 US) in Uganda in 1995 to that in 1996?
Provide a short and direct response. 0.79. What is the ratio of the Earning from trade(constant 2005 US) in Peru in 1995 to that in 1997?
Offer a terse response. 0.81. What is the ratio of the Earning from trade(constant 2005 US) in Trinidad and Tobago in 1995 to that in 1997?
Your answer should be compact. 0.96. What is the ratio of the Earning from trade(constant 2005 US) of Uganda in 1995 to that in 1997?
Keep it short and to the point. 0.61. What is the ratio of the Earning from trade(constant 2005 US) of Peru in 1995 to that in 1998?
Provide a succinct answer. 0.77. What is the ratio of the Earning from trade(constant 2005 US) of Trinidad and Tobago in 1995 to that in 1998?
Keep it short and to the point. 0.97. What is the ratio of the Earning from trade(constant 2005 US) in Uganda in 1995 to that in 1998?
Keep it short and to the point. 0.71. What is the ratio of the Earning from trade(constant 2005 US) of Peru in 1995 to that in 1999?
Provide a succinct answer. 0.71. What is the ratio of the Earning from trade(constant 2005 US) of Trinidad and Tobago in 1995 to that in 1999?
Give a very brief answer. 0.93. What is the ratio of the Earning from trade(constant 2005 US) of Uganda in 1995 to that in 1999?
Give a very brief answer. 0.56. What is the ratio of the Earning from trade(constant 2005 US) of Peru in 1995 to that in 2000?
Offer a terse response. 0.66. What is the ratio of the Earning from trade(constant 2005 US) of Trinidad and Tobago in 1995 to that in 2000?
Ensure brevity in your answer.  0.64. What is the ratio of the Earning from trade(constant 2005 US) in Uganda in 1995 to that in 2000?
Ensure brevity in your answer.  0.72. What is the ratio of the Earning from trade(constant 2005 US) of Peru in 1996 to that in 1997?
Ensure brevity in your answer.  0.88. What is the ratio of the Earning from trade(constant 2005 US) of Trinidad and Tobago in 1996 to that in 1997?
Make the answer very short. 0.88. What is the ratio of the Earning from trade(constant 2005 US) in Uganda in 1996 to that in 1997?
Your answer should be compact. 0.77. What is the ratio of the Earning from trade(constant 2005 US) of Peru in 1996 to that in 1998?
Your response must be concise. 0.84. What is the ratio of the Earning from trade(constant 2005 US) of Trinidad and Tobago in 1996 to that in 1998?
Your response must be concise. 0.88. What is the ratio of the Earning from trade(constant 2005 US) of Uganda in 1996 to that in 1998?
Provide a succinct answer. 0.91. What is the ratio of the Earning from trade(constant 2005 US) of Peru in 1996 to that in 1999?
Your response must be concise. 0.78. What is the ratio of the Earning from trade(constant 2005 US) in Trinidad and Tobago in 1996 to that in 1999?
Offer a very short reply. 0.85. What is the ratio of the Earning from trade(constant 2005 US) of Uganda in 1996 to that in 1999?
Your answer should be very brief. 0.72. What is the ratio of the Earning from trade(constant 2005 US) of Peru in 1996 to that in 2000?
Make the answer very short. 0.72. What is the ratio of the Earning from trade(constant 2005 US) in Trinidad and Tobago in 1996 to that in 2000?
Ensure brevity in your answer.  0.59. What is the ratio of the Earning from trade(constant 2005 US) of Uganda in 1996 to that in 2000?
Your answer should be very brief. 0.92. What is the ratio of the Earning from trade(constant 2005 US) of Peru in 1997 to that in 1998?
Your answer should be compact. 0.95. What is the ratio of the Earning from trade(constant 2005 US) of Trinidad and Tobago in 1997 to that in 1998?
Keep it short and to the point. 1.01. What is the ratio of the Earning from trade(constant 2005 US) of Uganda in 1997 to that in 1998?
Provide a short and direct response. 1.18. What is the ratio of the Earning from trade(constant 2005 US) of Peru in 1997 to that in 1999?
Your answer should be very brief. 0.88. What is the ratio of the Earning from trade(constant 2005 US) in Trinidad and Tobago in 1997 to that in 1999?
Offer a very short reply. 0.97. What is the ratio of the Earning from trade(constant 2005 US) of Uganda in 1997 to that in 1999?
Offer a very short reply. 0.93. What is the ratio of the Earning from trade(constant 2005 US) in Peru in 1997 to that in 2000?
Your answer should be very brief. 0.81. What is the ratio of the Earning from trade(constant 2005 US) of Trinidad and Tobago in 1997 to that in 2000?
Make the answer very short. 0.67. What is the ratio of the Earning from trade(constant 2005 US) of Uganda in 1997 to that in 2000?
Your answer should be compact. 1.19. What is the ratio of the Earning from trade(constant 2005 US) of Peru in 1998 to that in 1999?
Give a very brief answer. 0.93. What is the ratio of the Earning from trade(constant 2005 US) of Trinidad and Tobago in 1998 to that in 1999?
Provide a short and direct response. 0.97. What is the ratio of the Earning from trade(constant 2005 US) in Uganda in 1998 to that in 1999?
Offer a very short reply. 0.79. What is the ratio of the Earning from trade(constant 2005 US) in Peru in 1998 to that in 2000?
Your answer should be very brief. 0.86. What is the ratio of the Earning from trade(constant 2005 US) of Trinidad and Tobago in 1998 to that in 2000?
Ensure brevity in your answer.  0.67. What is the ratio of the Earning from trade(constant 2005 US) in Uganda in 1998 to that in 2000?
Your answer should be very brief. 1.01. What is the ratio of the Earning from trade(constant 2005 US) in Peru in 1999 to that in 2000?
Provide a short and direct response. 0.93. What is the ratio of the Earning from trade(constant 2005 US) in Trinidad and Tobago in 1999 to that in 2000?
Give a very brief answer. 0.69. What is the ratio of the Earning from trade(constant 2005 US) of Uganda in 1999 to that in 2000?
Your answer should be compact. 1.28. What is the difference between the highest and the second highest Earning from trade(constant 2005 US) in Peru?
Keep it short and to the point. 9.10e+08. What is the difference between the highest and the second highest Earning from trade(constant 2005 US) in Trinidad and Tobago?
Your response must be concise. 2.76e+09. What is the difference between the highest and the second highest Earning from trade(constant 2005 US) of Uganda?
Keep it short and to the point. 5.12e+07. What is the difference between the highest and the lowest Earning from trade(constant 2005 US) in Peru?
Your answer should be very brief. 5.84e+09. What is the difference between the highest and the lowest Earning from trade(constant 2005 US) in Trinidad and Tobago?
Your answer should be very brief. 4.06e+09. What is the difference between the highest and the lowest Earning from trade(constant 2005 US) in Uganda?
Your response must be concise. 4.92e+08. 